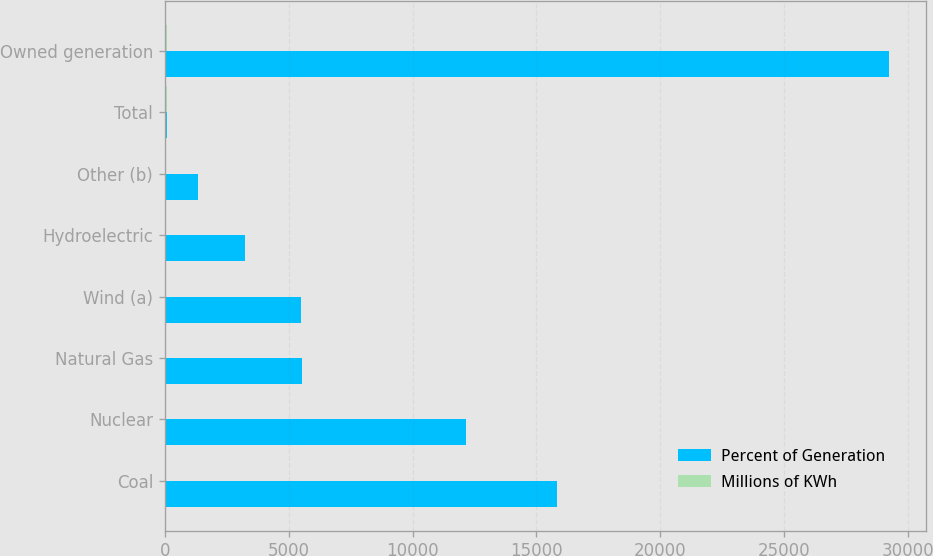Convert chart to OTSL. <chart><loc_0><loc_0><loc_500><loc_500><stacked_bar_chart><ecel><fcel>Coal<fcel>Nuclear<fcel>Natural Gas<fcel>Wind (a)<fcel>Hydroelectric<fcel>Other (b)<fcel>Total<fcel>Owned generation<nl><fcel>Percent of Generation<fcel>15844<fcel>12161<fcel>5550<fcel>5481<fcel>3223<fcel>1323<fcel>100<fcel>29249<nl><fcel>Millions of KWh<fcel>36<fcel>28<fcel>13<fcel>13<fcel>7<fcel>3<fcel>100<fcel>67<nl></chart> 